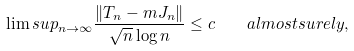<formula> <loc_0><loc_0><loc_500><loc_500>\lim s u p _ { n \to \infty } \frac { \| T _ { n } - m J _ { n } \| } { \sqrt { n } \log n } \leq c \quad a l m o s t s u r e l y ,</formula> 